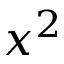<formula> <loc_0><loc_0><loc_500><loc_500>x ^ { 2 }</formula> 